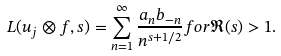Convert formula to latex. <formula><loc_0><loc_0><loc_500><loc_500>L ( u _ { j } \otimes f , s ) = \sum _ { n = 1 } ^ { \infty } \frac { a _ { n } b _ { - n } } { n ^ { s + 1 / 2 } } f o r \Re ( s ) > 1 .</formula> 